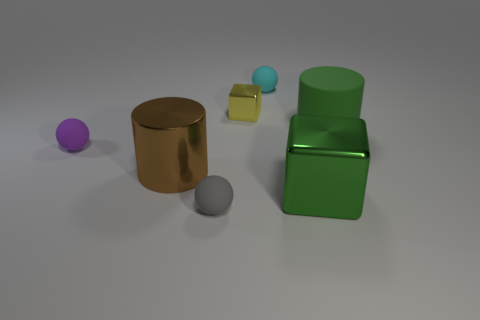What materials do the objects in the image seem to be made out of? The objects look like they are made from different materials. The spherical object on the left appears matte and could be plastic, the cylinder in the center has a reflective surface resembling metal, the small cube to its right seems metallic as well, and the two objects on the far right have a glossy finish that may suggest a glass or polished metal material. 